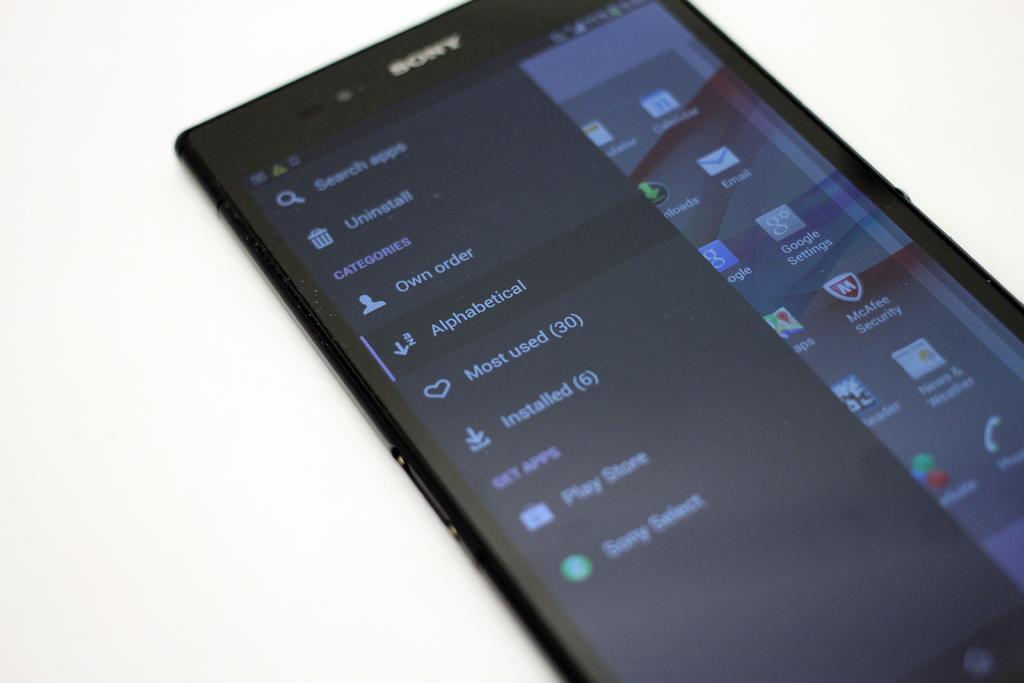What type of phone is this?
Your answer should be very brief. Sony. What option setting is currently highlighted on the screen?
Ensure brevity in your answer.  Alphabetical. 